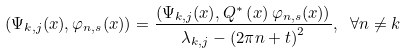<formula> <loc_0><loc_0><loc_500><loc_500>\left ( \Psi _ { k , j } ( x ) , \varphi _ { n , s } ( x ) \right ) = \frac { \left ( \Psi _ { k , j } ( x ) , Q ^ { \ast } \left ( x \right ) \varphi _ { n , s } ( x ) \right ) } { \lambda _ { k , j } - \left ( 2 \pi n + t \right ) ^ { 2 } } , \text { } \forall n \neq k</formula> 